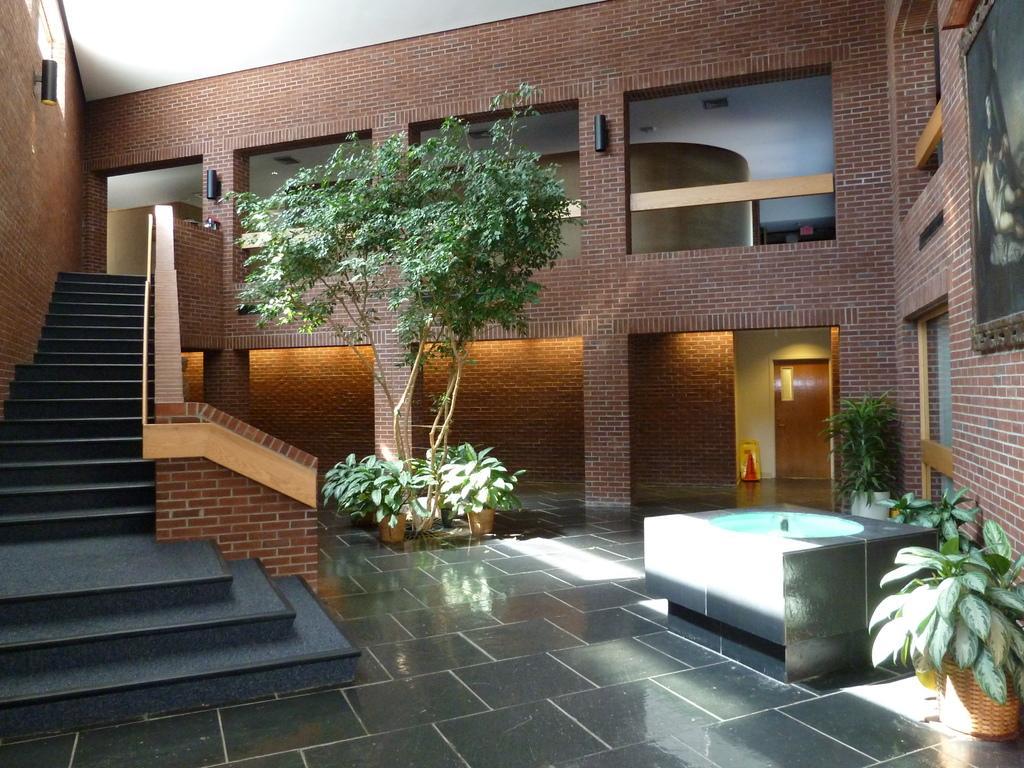How would you summarize this image in a sentence or two? In this image in the center there are plants. On the right side there is a door and a red colour stand and there is a wall. On the right side of the wall there is a frame. In front of the wall there are plants. On the left side there is a staircase. 